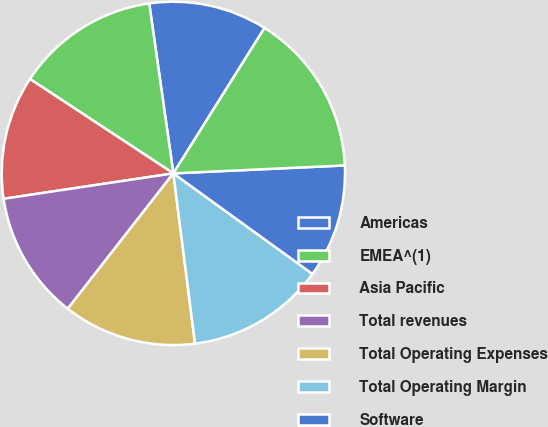Convert chart. <chart><loc_0><loc_0><loc_500><loc_500><pie_chart><fcel>Americas<fcel>EMEA^(1)<fcel>Asia Pacific<fcel>Total revenues<fcel>Total Operating Expenses<fcel>Total Operating Margin<fcel>Software<fcel>Services<nl><fcel>11.16%<fcel>13.49%<fcel>11.63%<fcel>12.09%<fcel>12.56%<fcel>13.02%<fcel>10.7%<fcel>15.35%<nl></chart> 